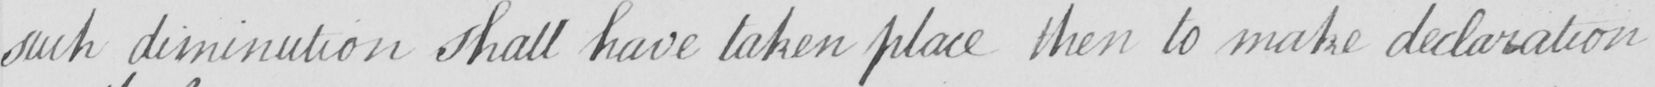Please transcribe the handwritten text in this image. such diminution shall have taken place then to make declaration 